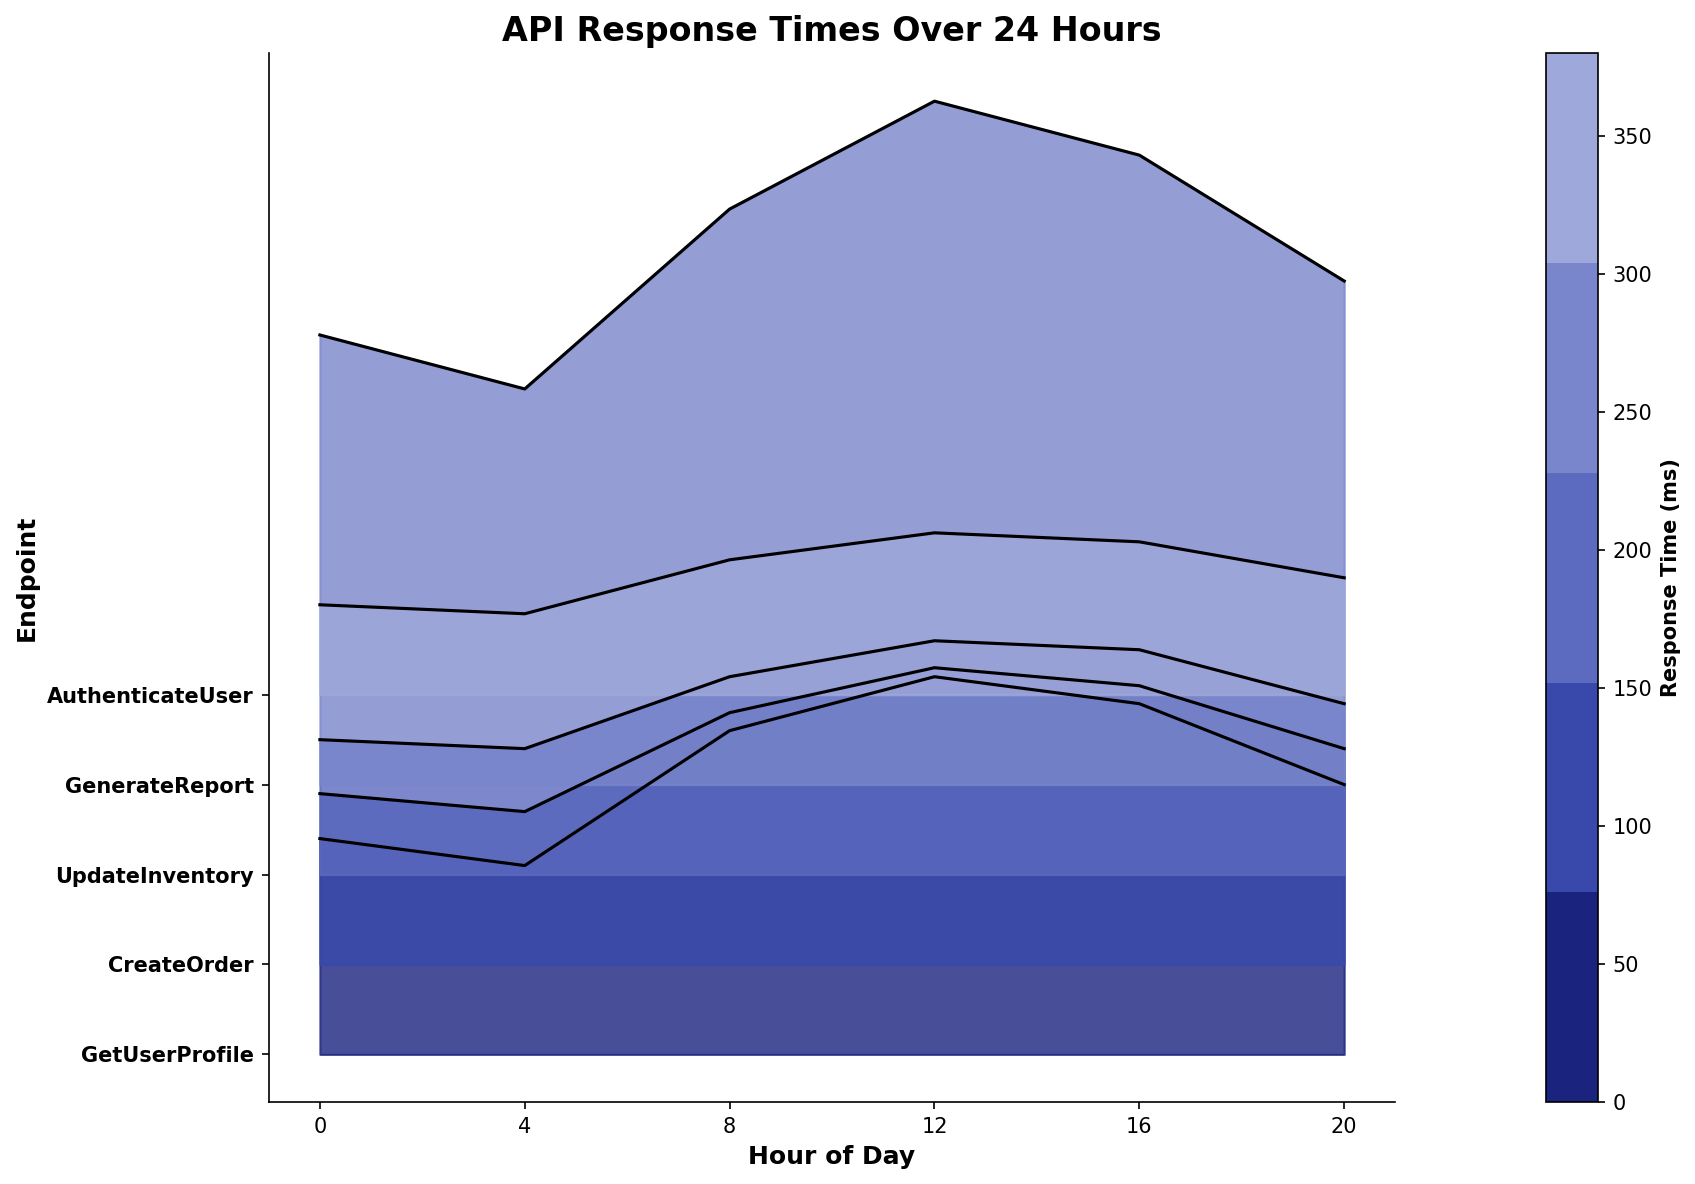What is the title of the plot? The title of the plot is clearly displayed at the top in bold. It helps to understand the overall subject of the visual representation.
Answer: API Response Times Over 24 Hours Which endpoint has the highest response time at noon? At noon (12th hour), observe the peaks in the ridgeline plot to identify the highest value. The 'GenerateReport' endpoint shows the highest response time.
Answer: GenerateReport How many endpoints are shown in the plot? Count the number of unique y-tick labels on the left side of the ridgeline plot.
Answer: 5 At which hour does 'GetUserProfile' have its lowest response time? Track the changes in the height of the ridgeline for 'GetUserProfile' across different hours to find the time with the minimum response. It has the lowest response time at the 4th hour.
Answer: 4 Compare the response times of 'CreateOrder' and 'AuthenticateUser' at 8 AM. Which endpoint has a higher response time? Look at the ridgelines for both 'CreateOrder' and 'AuthenticateUser' at the 8th hour and compare their heights. 'CreateOrder' has a higher response time.
Answer: CreateOrder What is the color gradient used in the plot? The plot uses a gradient of colors from dark blue to light blue, which indicates different ranges of response times.
Answer: Dark blue to light blue Does 'UpdateInventory' show a peak response time at 4 PM? Check the ridgeline plot for 'UpdateInventory' around the 16th hour to see if there is a significant peak. There is no notable peak at 4 PM.
Answer: No Which endpoint has the most stable (least variable) response times throughout the day? Compare how much the ridgelines for each endpoint fluctuate over the hours. 'AuthenticateUser' has the least variability.
Answer: AuthenticateUser By how much does the response time of 'GenerateReport' increase from 4 AM to 12 PM? Identify the response times of 'GenerateReport' at 4 AM and 12 PM from the plot and calculate the difference. Response time at 4 AM is 220 ms and at 12 PM is 380 ms, so the increase is 380 - 220 = 160 ms.
Answer: 160 ms At what hours does 'UpdateInventory' have a response time under 100 ms? Look at the ridgeline for 'UpdateInventory' and identify the hours where the response time is below 100 ms. These hours are 0, 4, and 20.
Answer: 0, 4, 20 